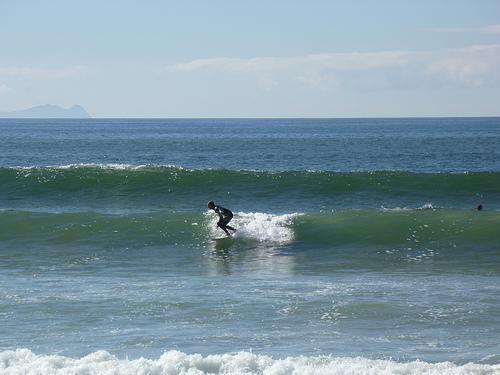How many waves are behind him?
Give a very brief answer. 2. How many people are in the water?
Give a very brief answer. 2. How many surfers are in this picture?
Give a very brief answer. 1. 